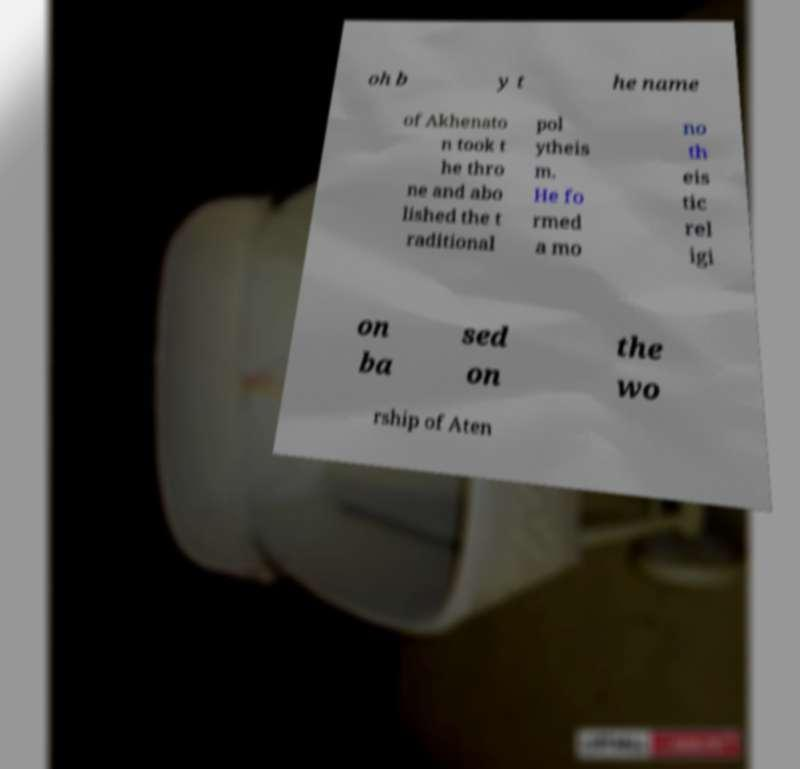There's text embedded in this image that I need extracted. Can you transcribe it verbatim? oh b y t he name of Akhenato n took t he thro ne and abo lished the t raditional pol ytheis m. He fo rmed a mo no th eis tic rel igi on ba sed on the wo rship of Aten 